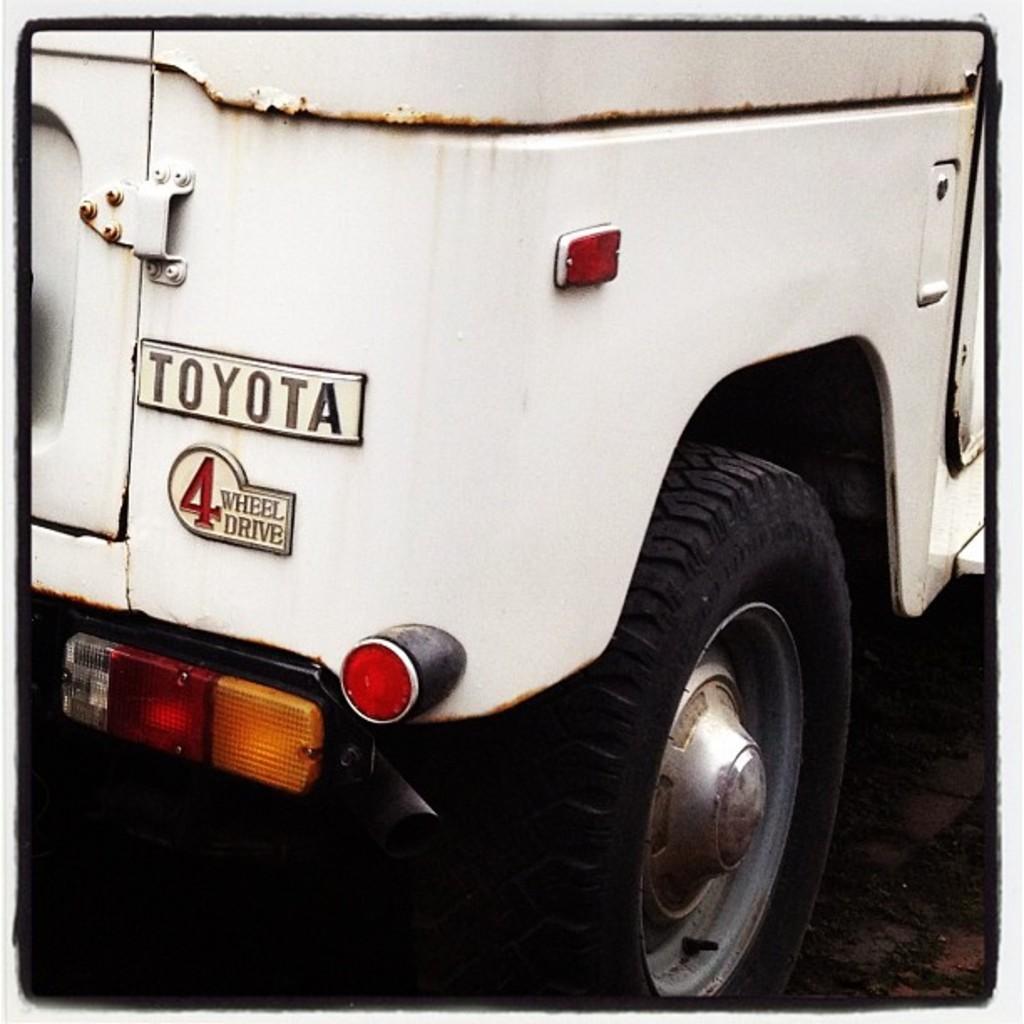Please provide a concise description of this image. In this image we can see the part of a motor vehicle placed on the ground. 